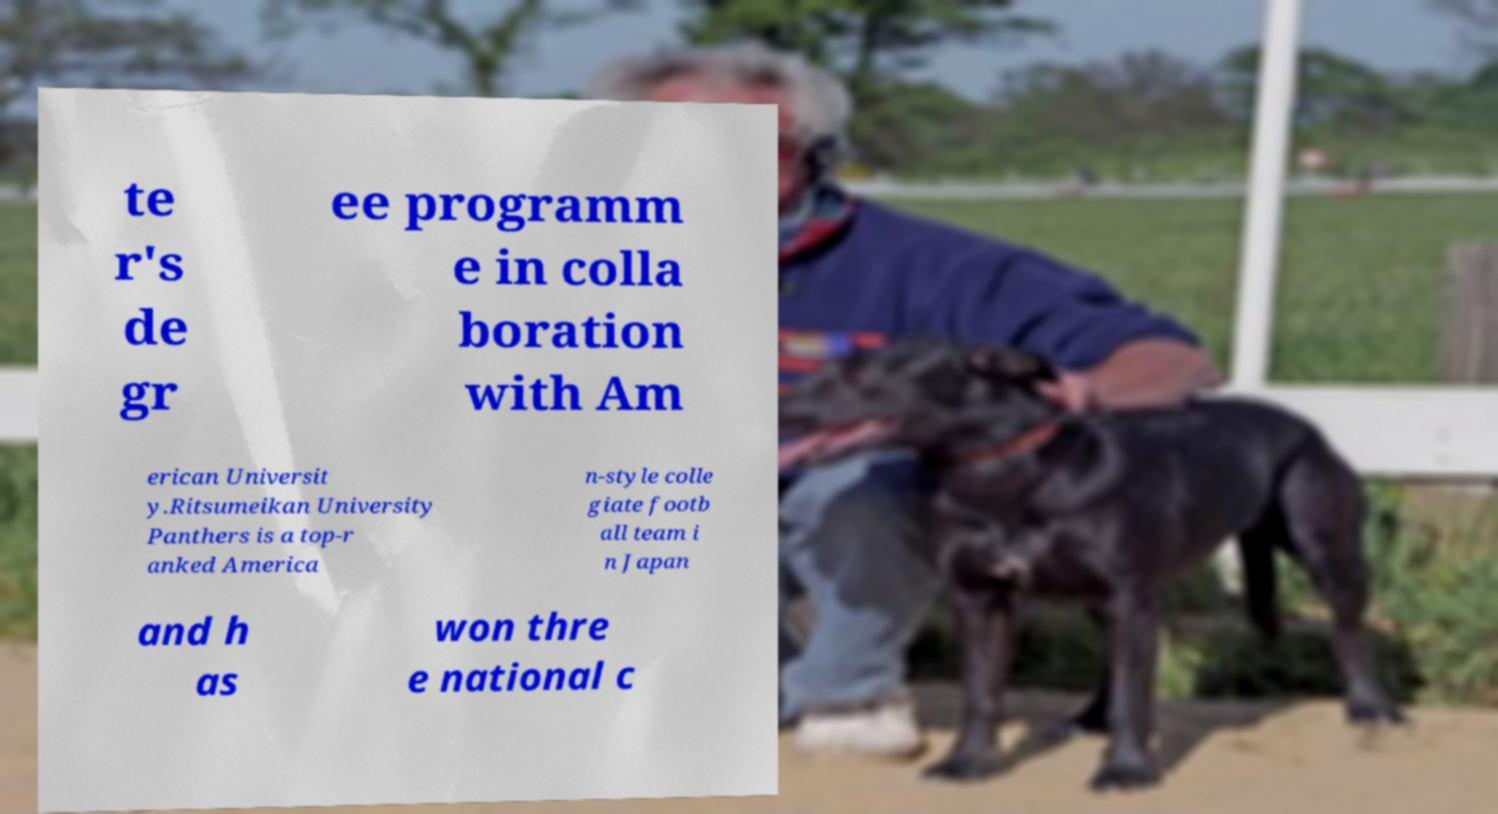Please read and relay the text visible in this image. What does it say? te r's de gr ee programm e in colla boration with Am erican Universit y.Ritsumeikan University Panthers is a top-r anked America n-style colle giate footb all team i n Japan and h as won thre e national c 